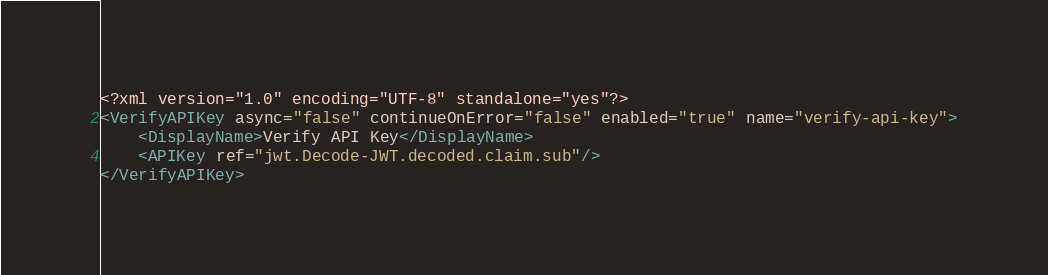Convert code to text. <code><loc_0><loc_0><loc_500><loc_500><_XML_><?xml version="1.0" encoding="UTF-8" standalone="yes"?>
<VerifyAPIKey async="false" continueOnError="false" enabled="true" name="verify-api-key">
    <DisplayName>Verify API Key</DisplayName>
    <APIKey ref="jwt.Decode-JWT.decoded.claim.sub"/>
</VerifyAPIKey></code> 